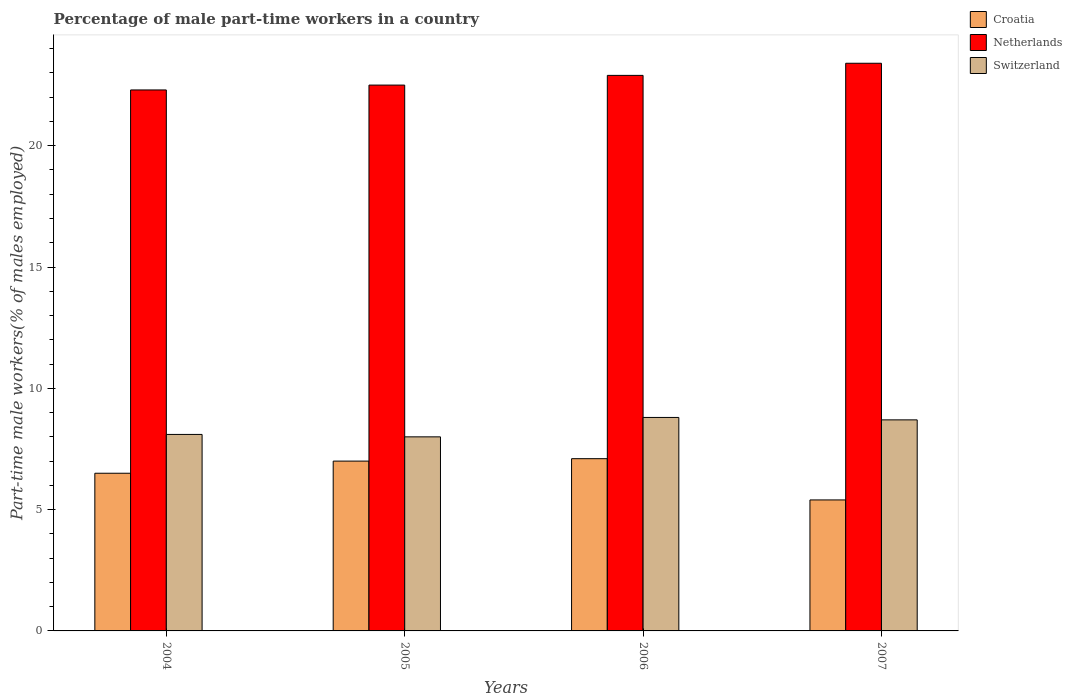How many groups of bars are there?
Give a very brief answer. 4. Are the number of bars per tick equal to the number of legend labels?
Give a very brief answer. Yes. Are the number of bars on each tick of the X-axis equal?
Your answer should be very brief. Yes. How many bars are there on the 3rd tick from the left?
Provide a succinct answer. 3. How many bars are there on the 1st tick from the right?
Keep it short and to the point. 3. What is the label of the 3rd group of bars from the left?
Your answer should be very brief. 2006. Across all years, what is the maximum percentage of male part-time workers in Croatia?
Offer a very short reply. 7.1. Across all years, what is the minimum percentage of male part-time workers in Croatia?
Provide a short and direct response. 5.4. What is the total percentage of male part-time workers in Croatia in the graph?
Your answer should be very brief. 26. What is the difference between the percentage of male part-time workers in Netherlands in 2006 and that in 2007?
Your response must be concise. -0.5. What is the difference between the percentage of male part-time workers in Croatia in 2007 and the percentage of male part-time workers in Switzerland in 2005?
Your response must be concise. -2.6. In the year 2007, what is the difference between the percentage of male part-time workers in Croatia and percentage of male part-time workers in Netherlands?
Make the answer very short. -18. In how many years, is the percentage of male part-time workers in Switzerland greater than 14 %?
Make the answer very short. 0. What is the ratio of the percentage of male part-time workers in Switzerland in 2005 to that in 2006?
Provide a short and direct response. 0.91. Is the percentage of male part-time workers in Netherlands in 2005 less than that in 2006?
Make the answer very short. Yes. Is the difference between the percentage of male part-time workers in Croatia in 2004 and 2006 greater than the difference between the percentage of male part-time workers in Netherlands in 2004 and 2006?
Provide a succinct answer. Yes. What is the difference between the highest and the lowest percentage of male part-time workers in Croatia?
Your answer should be compact. 1.7. In how many years, is the percentage of male part-time workers in Switzerland greater than the average percentage of male part-time workers in Switzerland taken over all years?
Ensure brevity in your answer.  2. What does the 1st bar from the left in 2007 represents?
Your answer should be compact. Croatia. What does the 1st bar from the right in 2007 represents?
Your answer should be compact. Switzerland. How many bars are there?
Ensure brevity in your answer.  12. Are all the bars in the graph horizontal?
Make the answer very short. No. How many years are there in the graph?
Your response must be concise. 4. What is the difference between two consecutive major ticks on the Y-axis?
Your response must be concise. 5. Does the graph contain any zero values?
Your answer should be compact. No. Does the graph contain grids?
Make the answer very short. No. Where does the legend appear in the graph?
Provide a succinct answer. Top right. What is the title of the graph?
Your answer should be very brief. Percentage of male part-time workers in a country. Does "St. Vincent and the Grenadines" appear as one of the legend labels in the graph?
Ensure brevity in your answer.  No. What is the label or title of the Y-axis?
Your answer should be compact. Part-time male workers(% of males employed). What is the Part-time male workers(% of males employed) of Netherlands in 2004?
Your answer should be compact. 22.3. What is the Part-time male workers(% of males employed) of Switzerland in 2004?
Your answer should be compact. 8.1. What is the Part-time male workers(% of males employed) of Switzerland in 2005?
Ensure brevity in your answer.  8. What is the Part-time male workers(% of males employed) of Croatia in 2006?
Your answer should be compact. 7.1. What is the Part-time male workers(% of males employed) of Netherlands in 2006?
Provide a succinct answer. 22.9. What is the Part-time male workers(% of males employed) in Switzerland in 2006?
Offer a terse response. 8.8. What is the Part-time male workers(% of males employed) in Croatia in 2007?
Provide a short and direct response. 5.4. What is the Part-time male workers(% of males employed) in Netherlands in 2007?
Ensure brevity in your answer.  23.4. What is the Part-time male workers(% of males employed) of Switzerland in 2007?
Offer a very short reply. 8.7. Across all years, what is the maximum Part-time male workers(% of males employed) in Croatia?
Ensure brevity in your answer.  7.1. Across all years, what is the maximum Part-time male workers(% of males employed) of Netherlands?
Your response must be concise. 23.4. Across all years, what is the maximum Part-time male workers(% of males employed) in Switzerland?
Offer a very short reply. 8.8. Across all years, what is the minimum Part-time male workers(% of males employed) of Croatia?
Your response must be concise. 5.4. Across all years, what is the minimum Part-time male workers(% of males employed) in Netherlands?
Provide a short and direct response. 22.3. What is the total Part-time male workers(% of males employed) in Netherlands in the graph?
Offer a very short reply. 91.1. What is the total Part-time male workers(% of males employed) in Switzerland in the graph?
Provide a succinct answer. 33.6. What is the difference between the Part-time male workers(% of males employed) of Croatia in 2004 and that in 2005?
Offer a very short reply. -0.5. What is the difference between the Part-time male workers(% of males employed) of Switzerland in 2004 and that in 2005?
Ensure brevity in your answer.  0.1. What is the difference between the Part-time male workers(% of males employed) in Croatia in 2004 and that in 2006?
Provide a succinct answer. -0.6. What is the difference between the Part-time male workers(% of males employed) in Netherlands in 2004 and that in 2006?
Your response must be concise. -0.6. What is the difference between the Part-time male workers(% of males employed) of Switzerland in 2004 and that in 2006?
Ensure brevity in your answer.  -0.7. What is the difference between the Part-time male workers(% of males employed) of Netherlands in 2004 and that in 2007?
Your response must be concise. -1.1. What is the difference between the Part-time male workers(% of males employed) of Switzerland in 2004 and that in 2007?
Your answer should be very brief. -0.6. What is the difference between the Part-time male workers(% of males employed) of Croatia in 2005 and that in 2006?
Your answer should be compact. -0.1. What is the difference between the Part-time male workers(% of males employed) of Netherlands in 2005 and that in 2006?
Your response must be concise. -0.4. What is the difference between the Part-time male workers(% of males employed) of Switzerland in 2005 and that in 2006?
Offer a very short reply. -0.8. What is the difference between the Part-time male workers(% of males employed) of Netherlands in 2005 and that in 2007?
Your answer should be very brief. -0.9. What is the difference between the Part-time male workers(% of males employed) in Switzerland in 2005 and that in 2007?
Make the answer very short. -0.7. What is the difference between the Part-time male workers(% of males employed) in Croatia in 2006 and that in 2007?
Your answer should be compact. 1.7. What is the difference between the Part-time male workers(% of males employed) in Netherlands in 2006 and that in 2007?
Ensure brevity in your answer.  -0.5. What is the difference between the Part-time male workers(% of males employed) in Switzerland in 2006 and that in 2007?
Your response must be concise. 0.1. What is the difference between the Part-time male workers(% of males employed) of Croatia in 2004 and the Part-time male workers(% of males employed) of Switzerland in 2005?
Your answer should be very brief. -1.5. What is the difference between the Part-time male workers(% of males employed) in Netherlands in 2004 and the Part-time male workers(% of males employed) in Switzerland in 2005?
Provide a short and direct response. 14.3. What is the difference between the Part-time male workers(% of males employed) in Croatia in 2004 and the Part-time male workers(% of males employed) in Netherlands in 2006?
Provide a succinct answer. -16.4. What is the difference between the Part-time male workers(% of males employed) in Croatia in 2004 and the Part-time male workers(% of males employed) in Switzerland in 2006?
Make the answer very short. -2.3. What is the difference between the Part-time male workers(% of males employed) in Netherlands in 2004 and the Part-time male workers(% of males employed) in Switzerland in 2006?
Your response must be concise. 13.5. What is the difference between the Part-time male workers(% of males employed) of Croatia in 2004 and the Part-time male workers(% of males employed) of Netherlands in 2007?
Provide a short and direct response. -16.9. What is the difference between the Part-time male workers(% of males employed) of Netherlands in 2004 and the Part-time male workers(% of males employed) of Switzerland in 2007?
Offer a terse response. 13.6. What is the difference between the Part-time male workers(% of males employed) in Croatia in 2005 and the Part-time male workers(% of males employed) in Netherlands in 2006?
Your answer should be very brief. -15.9. What is the difference between the Part-time male workers(% of males employed) in Croatia in 2005 and the Part-time male workers(% of males employed) in Switzerland in 2006?
Provide a short and direct response. -1.8. What is the difference between the Part-time male workers(% of males employed) of Netherlands in 2005 and the Part-time male workers(% of males employed) of Switzerland in 2006?
Make the answer very short. 13.7. What is the difference between the Part-time male workers(% of males employed) in Croatia in 2005 and the Part-time male workers(% of males employed) in Netherlands in 2007?
Make the answer very short. -16.4. What is the difference between the Part-time male workers(% of males employed) of Croatia in 2006 and the Part-time male workers(% of males employed) of Netherlands in 2007?
Make the answer very short. -16.3. What is the average Part-time male workers(% of males employed) in Croatia per year?
Make the answer very short. 6.5. What is the average Part-time male workers(% of males employed) of Netherlands per year?
Offer a terse response. 22.77. What is the average Part-time male workers(% of males employed) of Switzerland per year?
Your response must be concise. 8.4. In the year 2004, what is the difference between the Part-time male workers(% of males employed) in Croatia and Part-time male workers(% of males employed) in Netherlands?
Offer a terse response. -15.8. In the year 2004, what is the difference between the Part-time male workers(% of males employed) of Croatia and Part-time male workers(% of males employed) of Switzerland?
Ensure brevity in your answer.  -1.6. In the year 2004, what is the difference between the Part-time male workers(% of males employed) in Netherlands and Part-time male workers(% of males employed) in Switzerland?
Your response must be concise. 14.2. In the year 2005, what is the difference between the Part-time male workers(% of males employed) of Croatia and Part-time male workers(% of males employed) of Netherlands?
Your response must be concise. -15.5. In the year 2005, what is the difference between the Part-time male workers(% of males employed) of Croatia and Part-time male workers(% of males employed) of Switzerland?
Your response must be concise. -1. In the year 2005, what is the difference between the Part-time male workers(% of males employed) in Netherlands and Part-time male workers(% of males employed) in Switzerland?
Give a very brief answer. 14.5. In the year 2006, what is the difference between the Part-time male workers(% of males employed) of Croatia and Part-time male workers(% of males employed) of Netherlands?
Your answer should be compact. -15.8. In the year 2007, what is the difference between the Part-time male workers(% of males employed) of Netherlands and Part-time male workers(% of males employed) of Switzerland?
Ensure brevity in your answer.  14.7. What is the ratio of the Part-time male workers(% of males employed) of Croatia in 2004 to that in 2005?
Provide a succinct answer. 0.93. What is the ratio of the Part-time male workers(% of males employed) of Netherlands in 2004 to that in 2005?
Provide a succinct answer. 0.99. What is the ratio of the Part-time male workers(% of males employed) in Switzerland in 2004 to that in 2005?
Ensure brevity in your answer.  1.01. What is the ratio of the Part-time male workers(% of males employed) in Croatia in 2004 to that in 2006?
Your answer should be compact. 0.92. What is the ratio of the Part-time male workers(% of males employed) of Netherlands in 2004 to that in 2006?
Ensure brevity in your answer.  0.97. What is the ratio of the Part-time male workers(% of males employed) of Switzerland in 2004 to that in 2006?
Keep it short and to the point. 0.92. What is the ratio of the Part-time male workers(% of males employed) in Croatia in 2004 to that in 2007?
Your answer should be compact. 1.2. What is the ratio of the Part-time male workers(% of males employed) in Netherlands in 2004 to that in 2007?
Offer a terse response. 0.95. What is the ratio of the Part-time male workers(% of males employed) in Switzerland in 2004 to that in 2007?
Give a very brief answer. 0.93. What is the ratio of the Part-time male workers(% of males employed) of Croatia in 2005 to that in 2006?
Your answer should be compact. 0.99. What is the ratio of the Part-time male workers(% of males employed) of Netherlands in 2005 to that in 2006?
Make the answer very short. 0.98. What is the ratio of the Part-time male workers(% of males employed) in Switzerland in 2005 to that in 2006?
Give a very brief answer. 0.91. What is the ratio of the Part-time male workers(% of males employed) in Croatia in 2005 to that in 2007?
Provide a short and direct response. 1.3. What is the ratio of the Part-time male workers(% of males employed) of Netherlands in 2005 to that in 2007?
Offer a terse response. 0.96. What is the ratio of the Part-time male workers(% of males employed) in Switzerland in 2005 to that in 2007?
Provide a short and direct response. 0.92. What is the ratio of the Part-time male workers(% of males employed) in Croatia in 2006 to that in 2007?
Your answer should be compact. 1.31. What is the ratio of the Part-time male workers(% of males employed) of Netherlands in 2006 to that in 2007?
Offer a terse response. 0.98. What is the ratio of the Part-time male workers(% of males employed) in Switzerland in 2006 to that in 2007?
Keep it short and to the point. 1.01. What is the difference between the highest and the second highest Part-time male workers(% of males employed) of Croatia?
Offer a very short reply. 0.1. What is the difference between the highest and the second highest Part-time male workers(% of males employed) in Netherlands?
Give a very brief answer. 0.5. What is the difference between the highest and the second highest Part-time male workers(% of males employed) in Switzerland?
Make the answer very short. 0.1. What is the difference between the highest and the lowest Part-time male workers(% of males employed) in Croatia?
Keep it short and to the point. 1.7. What is the difference between the highest and the lowest Part-time male workers(% of males employed) in Switzerland?
Provide a succinct answer. 0.8. 